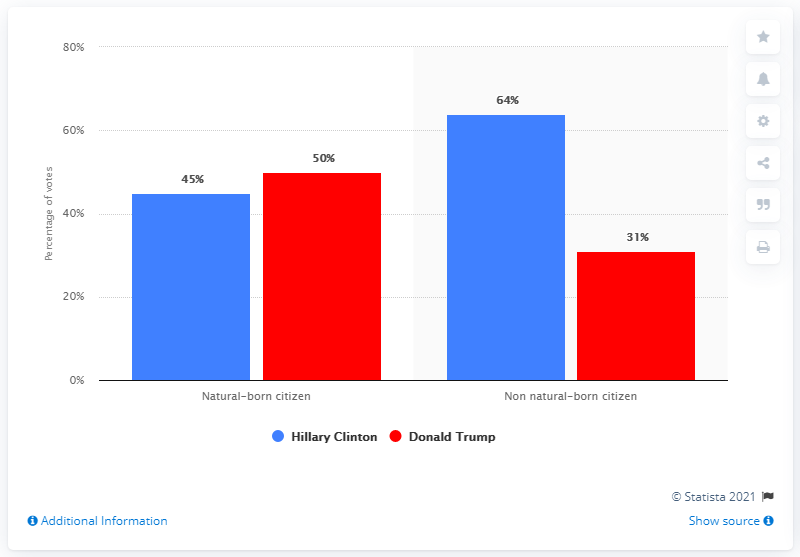List a handful of essential elements in this visual. The blue bar is not always taller than the red bar. According to the given data, the average percent of votes received by Hillary Clinton and Donald Trump from individuals of different immigrant statuses was 14%. 